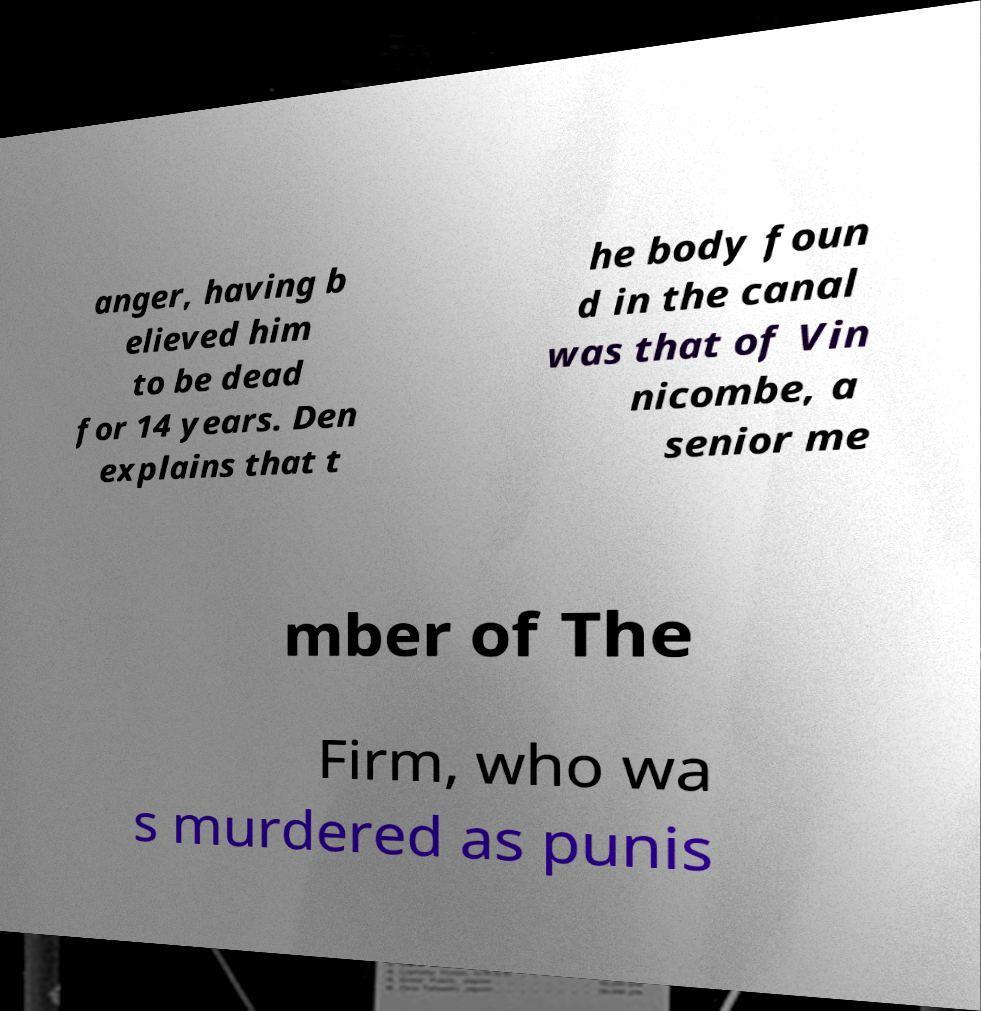Can you read and provide the text displayed in the image?This photo seems to have some interesting text. Can you extract and type it out for me? anger, having b elieved him to be dead for 14 years. Den explains that t he body foun d in the canal was that of Vin nicombe, a senior me mber of The Firm, who wa s murdered as punis 